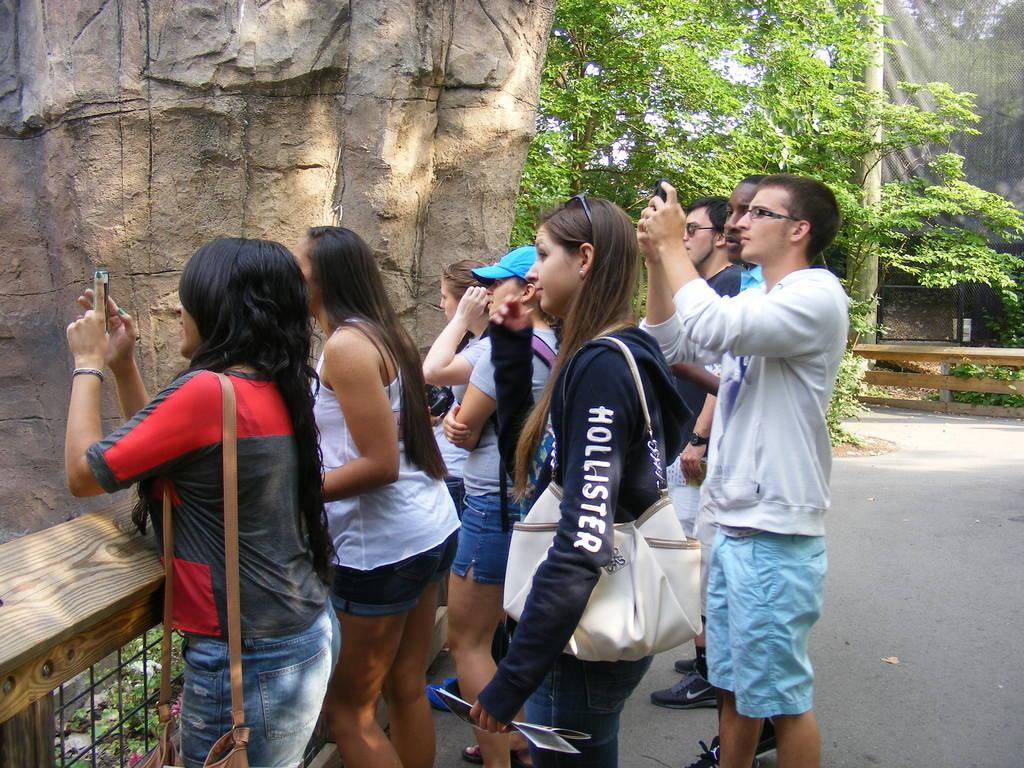How many people are in the image? There is a group of people in the image. Where are the people standing? The people are standing on a pathway. What can be seen in the background of the image? There are trees in the image. What type of structures are present in the image? There are fences in the image. Can you describe any other objects in the image? There is a pole and a rock in the image. Where is the stove located in the image? There is no stove present in the image. What type of lunchroom can be seen in the image? There is no lunchroom present in the image. 